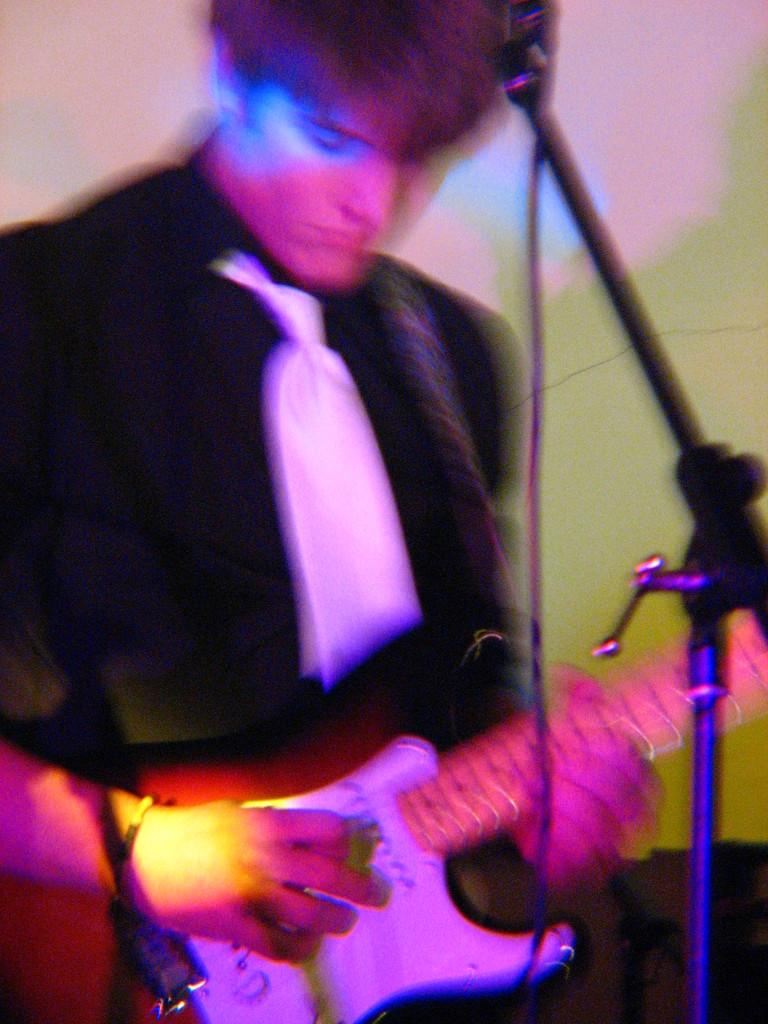What is the man in the image doing? The man is playing a guitar in the image. What object is present in the image that is commonly used for amplifying sound? There is a microphone (mike) in the image. What type of note is the man holding in the image? There is no note present in the image; the man is playing a guitar. How much tax is the man paying for the guitar in the image? There is no information about taxes in the image, as it only shows a man playing a guitar and a microphone. 